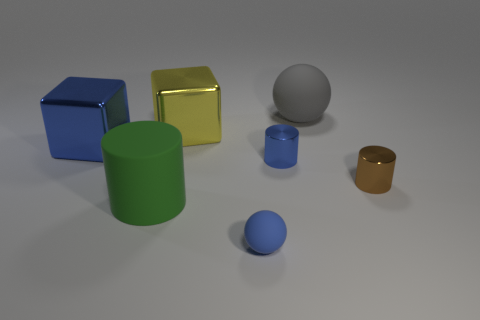What size is the cube that is the same color as the tiny matte thing?
Provide a short and direct response. Large. There is a large shiny thing that is the same color as the tiny rubber ball; what is its shape?
Make the answer very short. Cube. There is another thing that is the same shape as the big gray matte thing; what material is it?
Provide a succinct answer. Rubber. Is the number of brown shiny objects that are in front of the brown cylinder the same as the number of large cubes?
Your response must be concise. No. How big is the rubber object that is right of the green matte object and in front of the large rubber ball?
Give a very brief answer. Small. Is there anything else of the same color as the big sphere?
Your answer should be compact. No. There is a cylinder to the right of the matte object behind the large blue cube; how big is it?
Give a very brief answer. Small. There is a big object that is both to the right of the big blue cube and in front of the big yellow metallic block; what is its color?
Keep it short and to the point. Green. What number of other things are the same size as the blue metallic cylinder?
Provide a short and direct response. 2. Is the size of the green thing the same as the blue metallic thing that is right of the blue rubber thing?
Provide a short and direct response. No. 